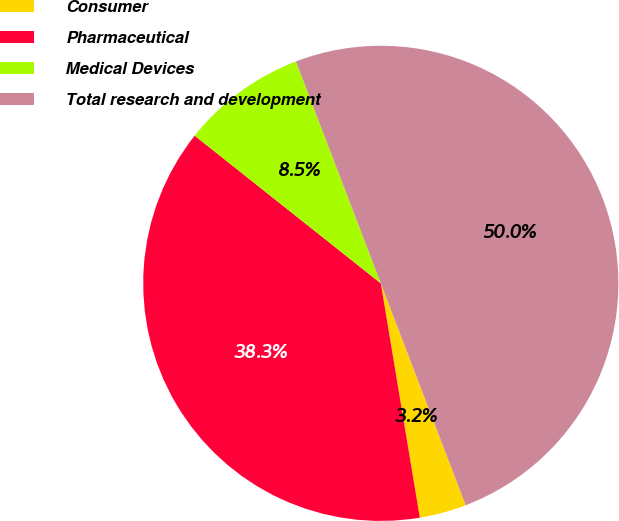Convert chart to OTSL. <chart><loc_0><loc_0><loc_500><loc_500><pie_chart><fcel>Consumer<fcel>Pharmaceutical<fcel>Medical Devices<fcel>Total research and development<nl><fcel>3.19%<fcel>38.3%<fcel>8.51%<fcel>50.0%<nl></chart> 